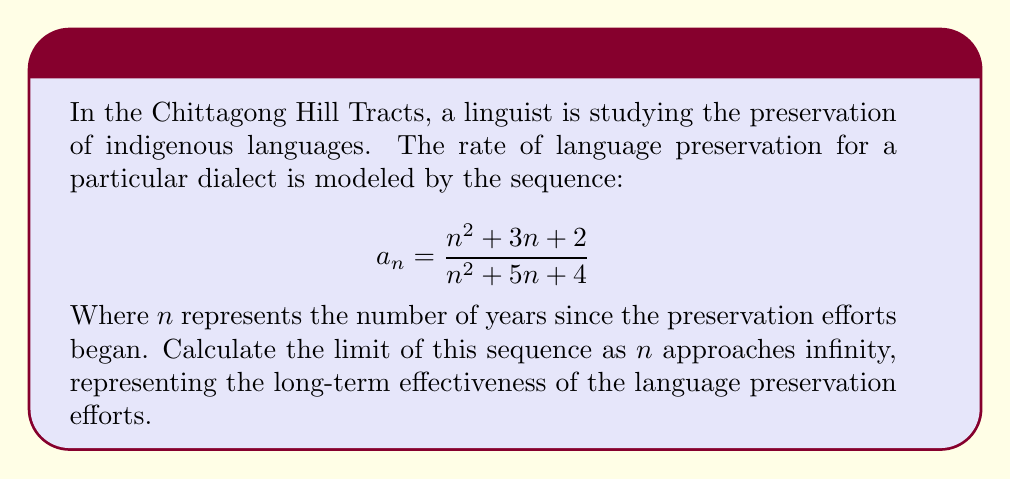Could you help me with this problem? To find the limit of the sequence as $n$ approaches infinity, we'll follow these steps:

1) First, let's examine the general term of the sequence:
   $$a_n = \frac{n^2 + 3n + 2}{n^2 + 5n + 4}$$

2) To find the limit, we need to consider the behavior of both the numerator and denominator as $n$ grows very large.

3) Divide both the numerator and denominator by the highest power of $n$, which is $n^2$:
   $$\lim_{n \to \infty} a_n = \lim_{n \to \infty} \frac{n^2/n^2 + 3n/n^2 + 2/n^2}{n^2/n^2 + 5n/n^2 + 4/n^2}$$

4) Simplify:
   $$\lim_{n \to \infty} a_n = \lim_{n \to \infty} \frac{1 + 3/n + 2/n^2}{1 + 5/n + 4/n^2}$$

5) As $n$ approaches infinity, $1/n$ and $1/n^2$ approach 0:
   $$\lim_{n \to \infty} a_n = \frac{1 + 0 + 0}{1 + 0 + 0} = \frac{1}{1} = 1$$

Thus, the limit of the sequence as $n$ approaches infinity is 1.
Answer: 1 